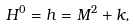Convert formula to latex. <formula><loc_0><loc_0><loc_500><loc_500>H ^ { 0 } = h = M ^ { 2 } + k ,</formula> 